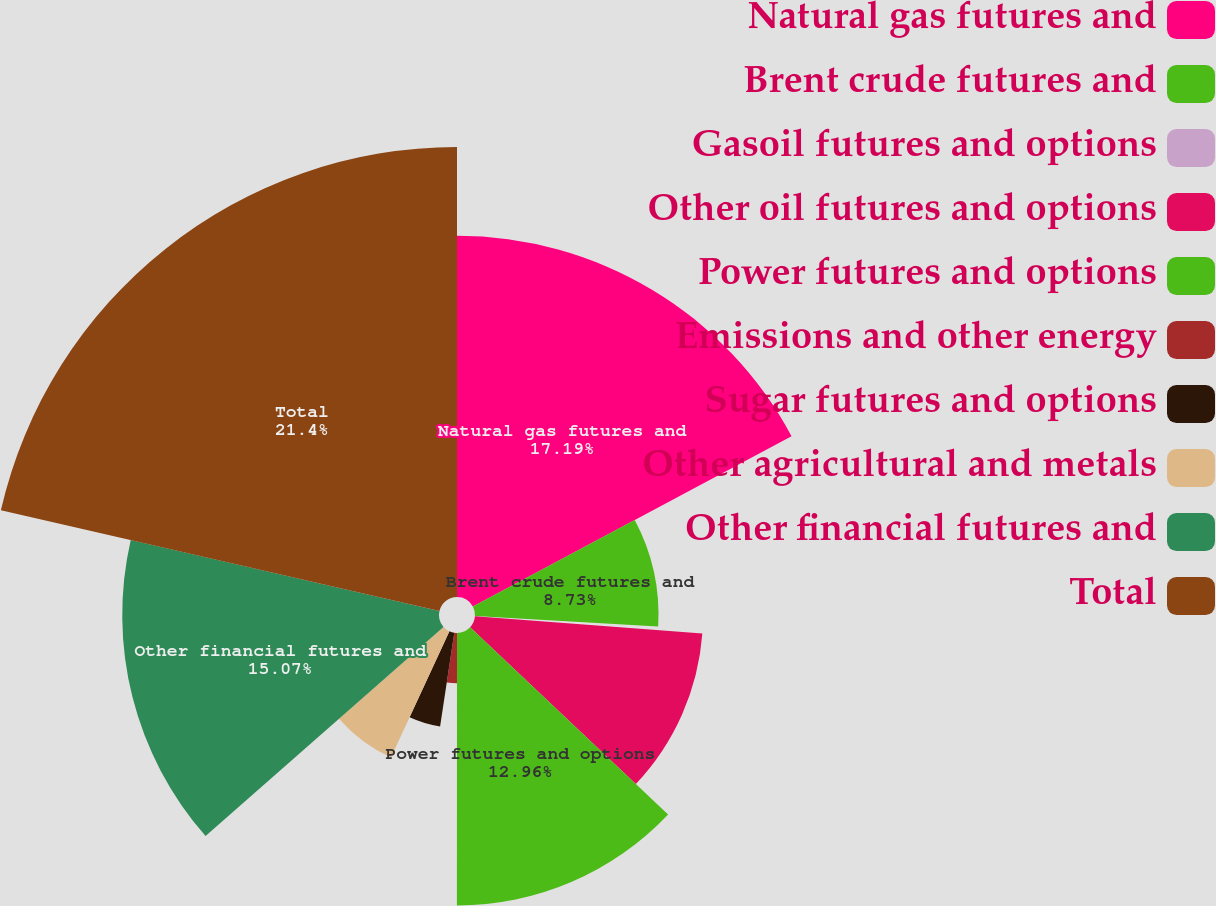Convert chart. <chart><loc_0><loc_0><loc_500><loc_500><pie_chart><fcel>Natural gas futures and<fcel>Brent crude futures and<fcel>Gasoil futures and options<fcel>Other oil futures and options<fcel>Power futures and options<fcel>Emissions and other energy<fcel>Sugar futures and options<fcel>Other agricultural and metals<fcel>Other financial futures and<fcel>Total<nl><fcel>17.19%<fcel>8.73%<fcel>0.28%<fcel>10.85%<fcel>12.96%<fcel>2.39%<fcel>4.51%<fcel>6.62%<fcel>15.07%<fcel>21.41%<nl></chart> 